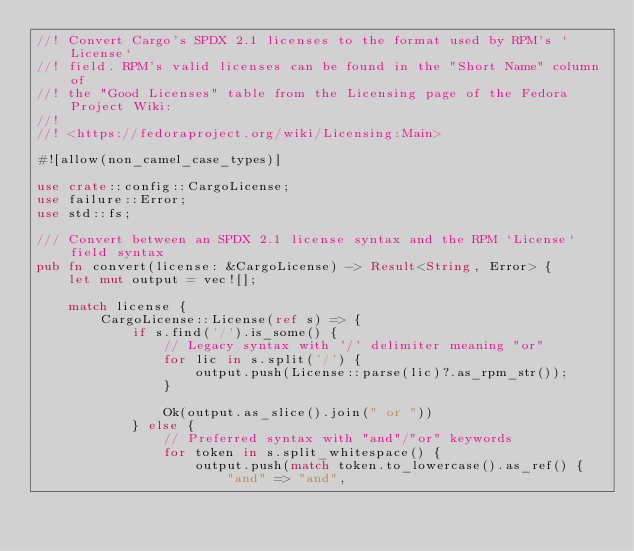<code> <loc_0><loc_0><loc_500><loc_500><_Rust_>//! Convert Cargo's SPDX 2.1 licenses to the format used by RPM's `License`
//! field. RPM's valid licenses can be found in the "Short Name" column of
//! the "Good Licenses" table from the Licensing page of the Fedora Project Wiki:
//!
//! <https://fedoraproject.org/wiki/Licensing:Main>

#![allow(non_camel_case_types)]

use crate::config::CargoLicense;
use failure::Error;
use std::fs;

/// Convert between an SPDX 2.1 license syntax and the RPM `License` field syntax
pub fn convert(license: &CargoLicense) -> Result<String, Error> {
    let mut output = vec![];

    match license {
        CargoLicense::License(ref s) => {
            if s.find('/').is_some() {
                // Legacy syntax with '/' delimiter meaning "or"
                for lic in s.split('/') {
                    output.push(License::parse(lic)?.as_rpm_str());
                }

                Ok(output.as_slice().join(" or "))
            } else {
                // Preferred syntax with "and"/"or" keywords
                for token in s.split_whitespace() {
                    output.push(match token.to_lowercase().as_ref() {
                        "and" => "and",</code> 